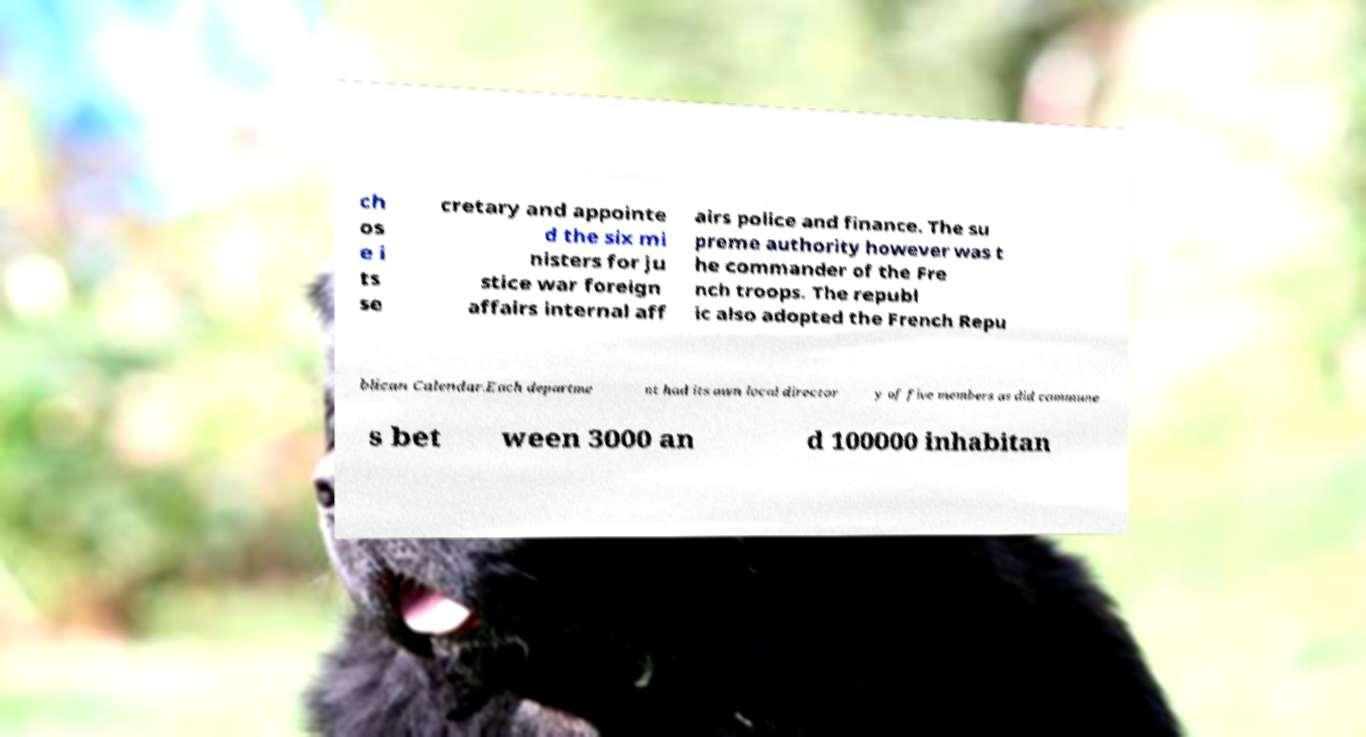Could you assist in decoding the text presented in this image and type it out clearly? ch os e i ts se cretary and appointe d the six mi nisters for ju stice war foreign affairs internal aff airs police and finance. The su preme authority however was t he commander of the Fre nch troops. The republ ic also adopted the French Repu blican Calendar.Each departme nt had its own local director y of five members as did commune s bet ween 3000 an d 100000 inhabitan 